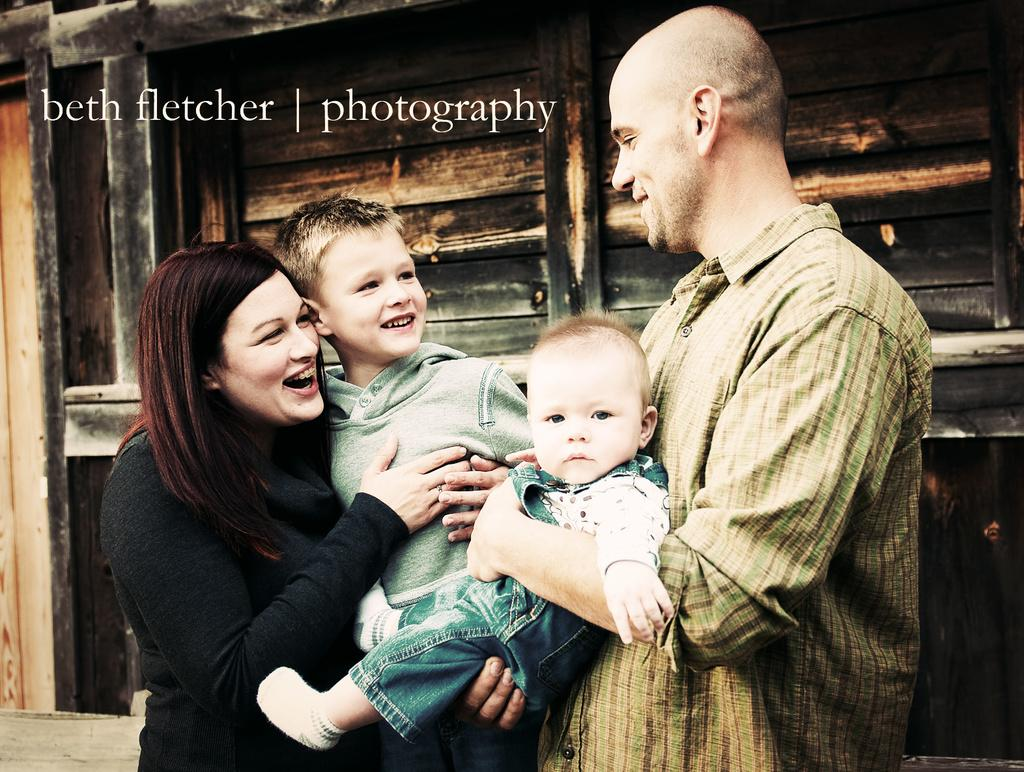How many people are in the image? There are four people in the image: a man, a woman, and two children. What are the people in the image doing? The people in the image are smiling. What can be seen in the background of the image? There is a wooden wall in the background of the image. What time of day is it in the image, and how does the achiever feel? The time of day is not mentioned in the image, and there is no achiever present. 